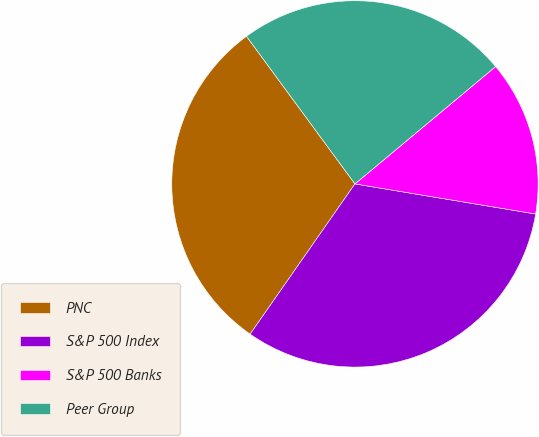Convert chart. <chart><loc_0><loc_0><loc_500><loc_500><pie_chart><fcel>PNC<fcel>S&P 500 Index<fcel>S&P 500 Banks<fcel>Peer Group<nl><fcel>30.22%<fcel>32.07%<fcel>13.69%<fcel>24.02%<nl></chart> 